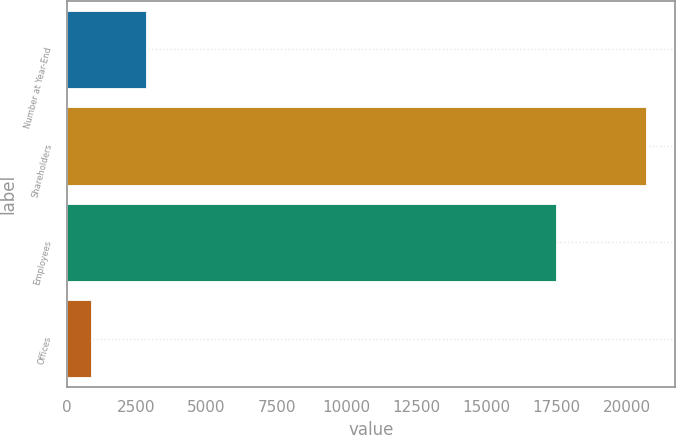<chart> <loc_0><loc_0><loc_500><loc_500><bar_chart><fcel>Number at Year-End<fcel>Shareholders<fcel>Employees<fcel>Offices<nl><fcel>2846<fcel>20693<fcel>17476<fcel>863<nl></chart> 